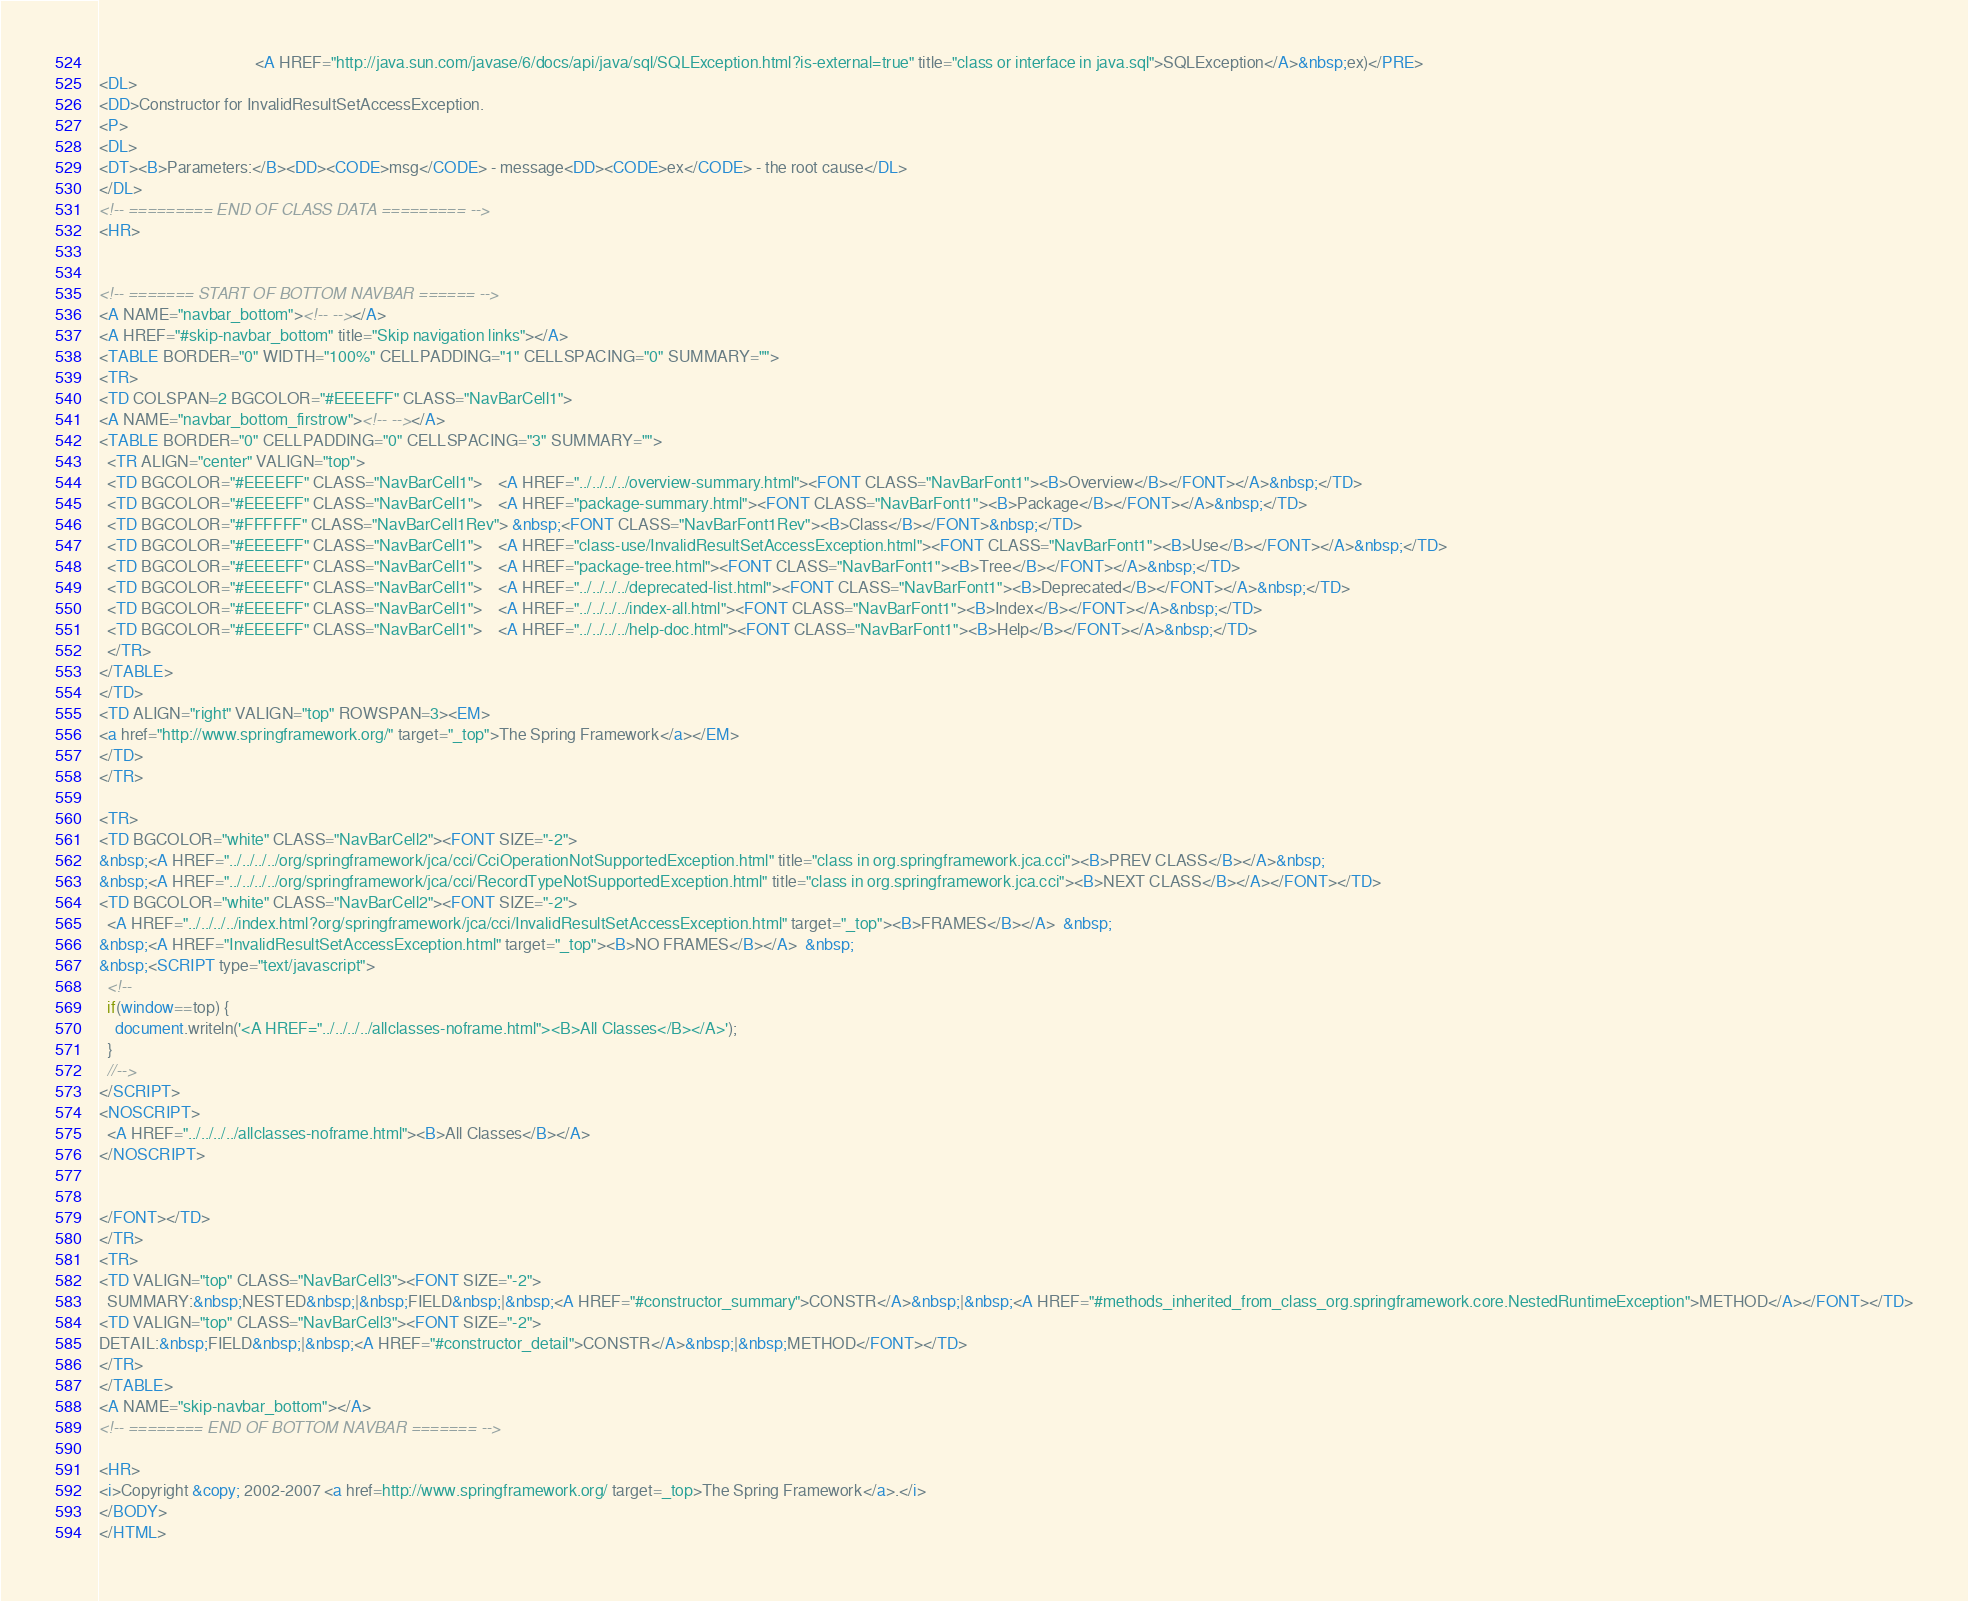<code> <loc_0><loc_0><loc_500><loc_500><_HTML_>                                       <A HREF="http://java.sun.com/javase/6/docs/api/java/sql/SQLException.html?is-external=true" title="class or interface in java.sql">SQLException</A>&nbsp;ex)</PRE>
<DL>
<DD>Constructor for InvalidResultSetAccessException.
<P>
<DL>
<DT><B>Parameters:</B><DD><CODE>msg</CODE> - message<DD><CODE>ex</CODE> - the root cause</DL>
</DL>
<!-- ========= END OF CLASS DATA ========= -->
<HR>


<!-- ======= START OF BOTTOM NAVBAR ====== -->
<A NAME="navbar_bottom"><!-- --></A>
<A HREF="#skip-navbar_bottom" title="Skip navigation links"></A>
<TABLE BORDER="0" WIDTH="100%" CELLPADDING="1" CELLSPACING="0" SUMMARY="">
<TR>
<TD COLSPAN=2 BGCOLOR="#EEEEFF" CLASS="NavBarCell1">
<A NAME="navbar_bottom_firstrow"><!-- --></A>
<TABLE BORDER="0" CELLPADDING="0" CELLSPACING="3" SUMMARY="">
  <TR ALIGN="center" VALIGN="top">
  <TD BGCOLOR="#EEEEFF" CLASS="NavBarCell1">    <A HREF="../../../../overview-summary.html"><FONT CLASS="NavBarFont1"><B>Overview</B></FONT></A>&nbsp;</TD>
  <TD BGCOLOR="#EEEEFF" CLASS="NavBarCell1">    <A HREF="package-summary.html"><FONT CLASS="NavBarFont1"><B>Package</B></FONT></A>&nbsp;</TD>
  <TD BGCOLOR="#FFFFFF" CLASS="NavBarCell1Rev"> &nbsp;<FONT CLASS="NavBarFont1Rev"><B>Class</B></FONT>&nbsp;</TD>
  <TD BGCOLOR="#EEEEFF" CLASS="NavBarCell1">    <A HREF="class-use/InvalidResultSetAccessException.html"><FONT CLASS="NavBarFont1"><B>Use</B></FONT></A>&nbsp;</TD>
  <TD BGCOLOR="#EEEEFF" CLASS="NavBarCell1">    <A HREF="package-tree.html"><FONT CLASS="NavBarFont1"><B>Tree</B></FONT></A>&nbsp;</TD>
  <TD BGCOLOR="#EEEEFF" CLASS="NavBarCell1">    <A HREF="../../../../deprecated-list.html"><FONT CLASS="NavBarFont1"><B>Deprecated</B></FONT></A>&nbsp;</TD>
  <TD BGCOLOR="#EEEEFF" CLASS="NavBarCell1">    <A HREF="../../../../index-all.html"><FONT CLASS="NavBarFont1"><B>Index</B></FONT></A>&nbsp;</TD>
  <TD BGCOLOR="#EEEEFF" CLASS="NavBarCell1">    <A HREF="../../../../help-doc.html"><FONT CLASS="NavBarFont1"><B>Help</B></FONT></A>&nbsp;</TD>
  </TR>
</TABLE>
</TD>
<TD ALIGN="right" VALIGN="top" ROWSPAN=3><EM>
<a href="http://www.springframework.org/" target="_top">The Spring Framework</a></EM>
</TD>
</TR>

<TR>
<TD BGCOLOR="white" CLASS="NavBarCell2"><FONT SIZE="-2">
&nbsp;<A HREF="../../../../org/springframework/jca/cci/CciOperationNotSupportedException.html" title="class in org.springframework.jca.cci"><B>PREV CLASS</B></A>&nbsp;
&nbsp;<A HREF="../../../../org/springframework/jca/cci/RecordTypeNotSupportedException.html" title="class in org.springframework.jca.cci"><B>NEXT CLASS</B></A></FONT></TD>
<TD BGCOLOR="white" CLASS="NavBarCell2"><FONT SIZE="-2">
  <A HREF="../../../../index.html?org/springframework/jca/cci/InvalidResultSetAccessException.html" target="_top"><B>FRAMES</B></A>  &nbsp;
&nbsp;<A HREF="InvalidResultSetAccessException.html" target="_top"><B>NO FRAMES</B></A>  &nbsp;
&nbsp;<SCRIPT type="text/javascript">
  <!--
  if(window==top) {
    document.writeln('<A HREF="../../../../allclasses-noframe.html"><B>All Classes</B></A>');
  }
  //-->
</SCRIPT>
<NOSCRIPT>
  <A HREF="../../../../allclasses-noframe.html"><B>All Classes</B></A>
</NOSCRIPT>


</FONT></TD>
</TR>
<TR>
<TD VALIGN="top" CLASS="NavBarCell3"><FONT SIZE="-2">
  SUMMARY:&nbsp;NESTED&nbsp;|&nbsp;FIELD&nbsp;|&nbsp;<A HREF="#constructor_summary">CONSTR</A>&nbsp;|&nbsp;<A HREF="#methods_inherited_from_class_org.springframework.core.NestedRuntimeException">METHOD</A></FONT></TD>
<TD VALIGN="top" CLASS="NavBarCell3"><FONT SIZE="-2">
DETAIL:&nbsp;FIELD&nbsp;|&nbsp;<A HREF="#constructor_detail">CONSTR</A>&nbsp;|&nbsp;METHOD</FONT></TD>
</TR>
</TABLE>
<A NAME="skip-navbar_bottom"></A>
<!-- ======== END OF BOTTOM NAVBAR ======= -->

<HR>
<i>Copyright &copy; 2002-2007 <a href=http://www.springframework.org/ target=_top>The Spring Framework</a>.</i>
</BODY>
</HTML>
</code> 